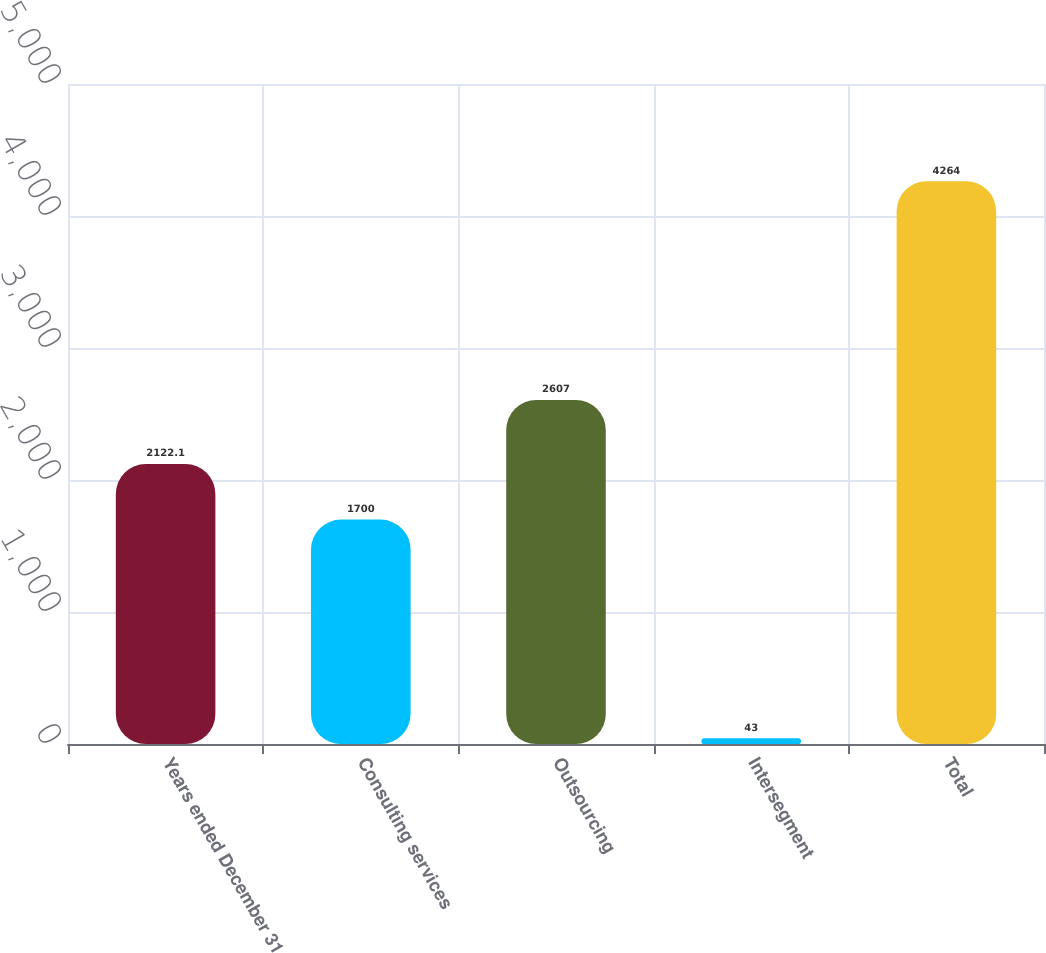Convert chart to OTSL. <chart><loc_0><loc_0><loc_500><loc_500><bar_chart><fcel>Years ended December 31<fcel>Consulting services<fcel>Outsourcing<fcel>Intersegment<fcel>Total<nl><fcel>2122.1<fcel>1700<fcel>2607<fcel>43<fcel>4264<nl></chart> 